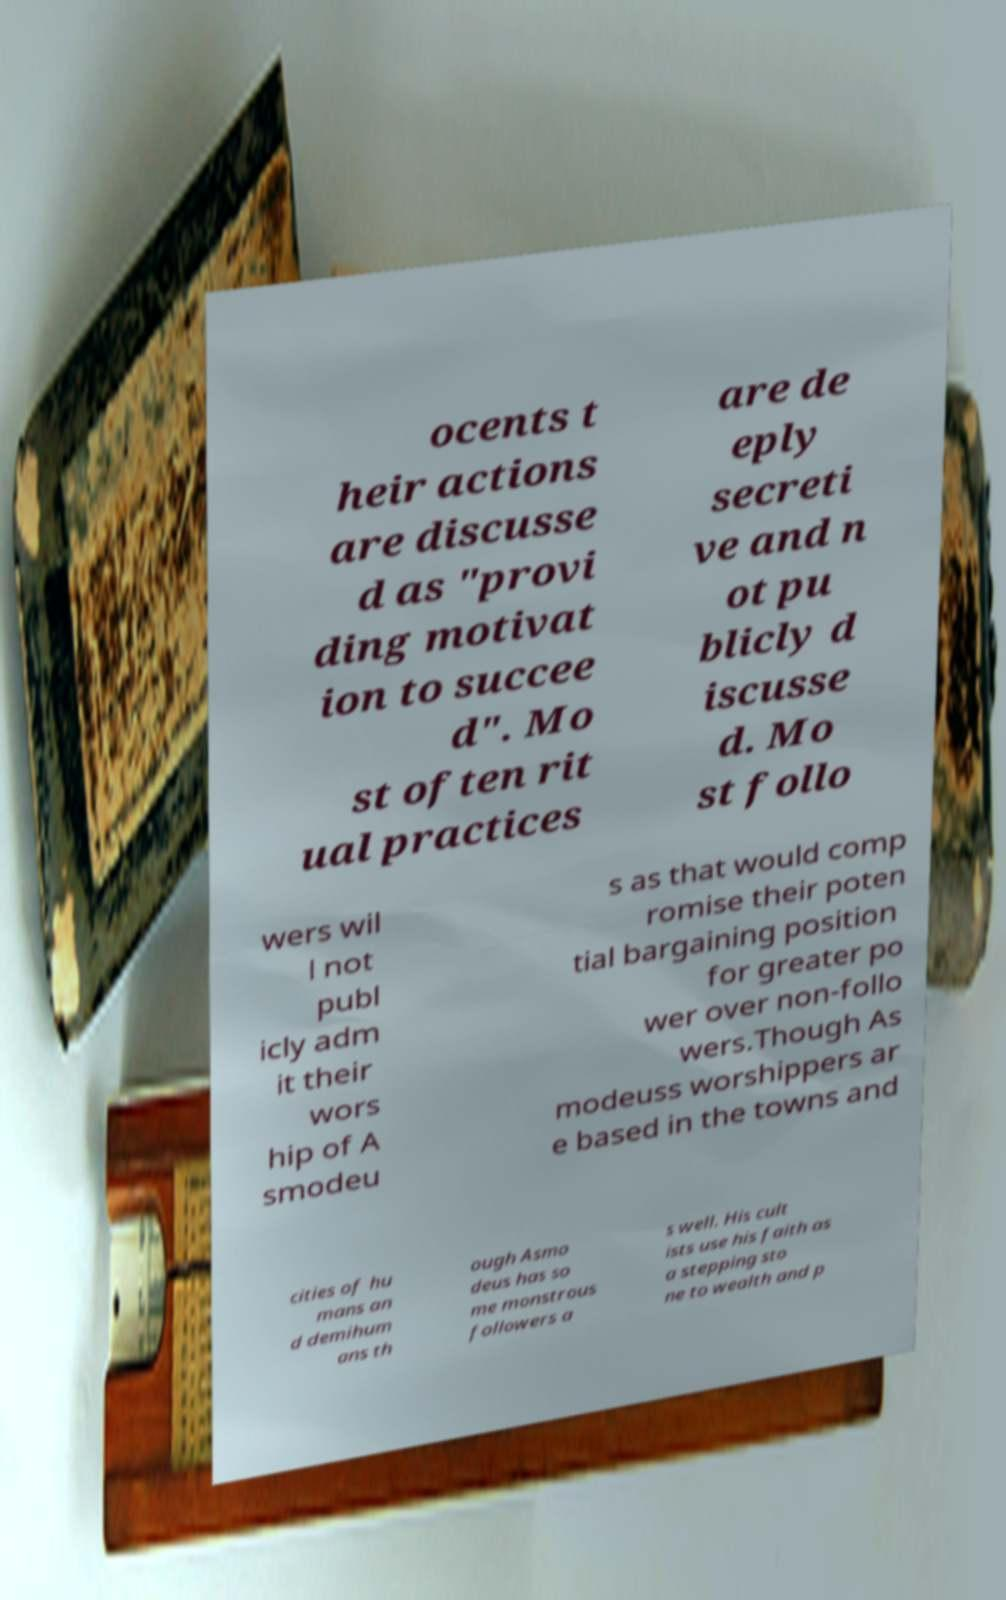Please identify and transcribe the text found in this image. ocents t heir actions are discusse d as "provi ding motivat ion to succee d". Mo st often rit ual practices are de eply secreti ve and n ot pu blicly d iscusse d. Mo st follo wers wil l not publ icly adm it their wors hip of A smodeu s as that would comp romise their poten tial bargaining position for greater po wer over non-follo wers.Though As modeuss worshippers ar e based in the towns and cities of hu mans an d demihum ans th ough Asmo deus has so me monstrous followers a s well. His cult ists use his faith as a stepping sto ne to wealth and p 